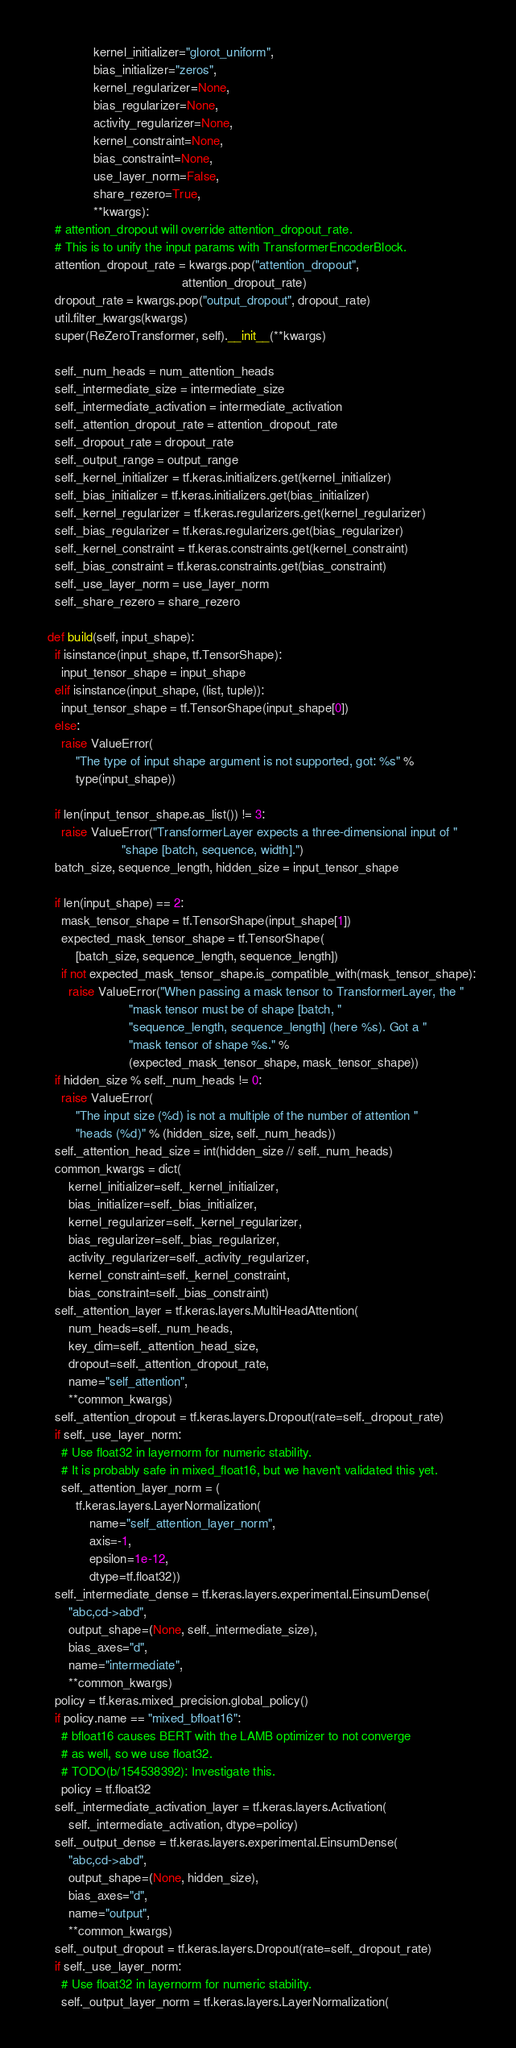Convert code to text. <code><loc_0><loc_0><loc_500><loc_500><_Python_>               kernel_initializer="glorot_uniform",
               bias_initializer="zeros",
               kernel_regularizer=None,
               bias_regularizer=None,
               activity_regularizer=None,
               kernel_constraint=None,
               bias_constraint=None,
               use_layer_norm=False,
               share_rezero=True,
               **kwargs):
    # attention_dropout will override attention_dropout_rate.
    # This is to unify the input params with TransformerEncoderBlock.
    attention_dropout_rate = kwargs.pop("attention_dropout",
                                        attention_dropout_rate)
    dropout_rate = kwargs.pop("output_dropout", dropout_rate)
    util.filter_kwargs(kwargs)
    super(ReZeroTransformer, self).__init__(**kwargs)

    self._num_heads = num_attention_heads
    self._intermediate_size = intermediate_size
    self._intermediate_activation = intermediate_activation
    self._attention_dropout_rate = attention_dropout_rate
    self._dropout_rate = dropout_rate
    self._output_range = output_range
    self._kernel_initializer = tf.keras.initializers.get(kernel_initializer)
    self._bias_initializer = tf.keras.initializers.get(bias_initializer)
    self._kernel_regularizer = tf.keras.regularizers.get(kernel_regularizer)
    self._bias_regularizer = tf.keras.regularizers.get(bias_regularizer)
    self._kernel_constraint = tf.keras.constraints.get(kernel_constraint)
    self._bias_constraint = tf.keras.constraints.get(bias_constraint)
    self._use_layer_norm = use_layer_norm
    self._share_rezero = share_rezero

  def build(self, input_shape):
    if isinstance(input_shape, tf.TensorShape):
      input_tensor_shape = input_shape
    elif isinstance(input_shape, (list, tuple)):
      input_tensor_shape = tf.TensorShape(input_shape[0])
    else:
      raise ValueError(
          "The type of input shape argument is not supported, got: %s" %
          type(input_shape))

    if len(input_tensor_shape.as_list()) != 3:
      raise ValueError("TransformerLayer expects a three-dimensional input of "
                       "shape [batch, sequence, width].")
    batch_size, sequence_length, hidden_size = input_tensor_shape

    if len(input_shape) == 2:
      mask_tensor_shape = tf.TensorShape(input_shape[1])
      expected_mask_tensor_shape = tf.TensorShape(
          [batch_size, sequence_length, sequence_length])
      if not expected_mask_tensor_shape.is_compatible_with(mask_tensor_shape):
        raise ValueError("When passing a mask tensor to TransformerLayer, the "
                         "mask tensor must be of shape [batch, "
                         "sequence_length, sequence_length] (here %s). Got a "
                         "mask tensor of shape %s." %
                         (expected_mask_tensor_shape, mask_tensor_shape))
    if hidden_size % self._num_heads != 0:
      raise ValueError(
          "The input size (%d) is not a multiple of the number of attention "
          "heads (%d)" % (hidden_size, self._num_heads))
    self._attention_head_size = int(hidden_size // self._num_heads)
    common_kwargs = dict(
        kernel_initializer=self._kernel_initializer,
        bias_initializer=self._bias_initializer,
        kernel_regularizer=self._kernel_regularizer,
        bias_regularizer=self._bias_regularizer,
        activity_regularizer=self._activity_regularizer,
        kernel_constraint=self._kernel_constraint,
        bias_constraint=self._bias_constraint)
    self._attention_layer = tf.keras.layers.MultiHeadAttention(
        num_heads=self._num_heads,
        key_dim=self._attention_head_size,
        dropout=self._attention_dropout_rate,
        name="self_attention",
        **common_kwargs)
    self._attention_dropout = tf.keras.layers.Dropout(rate=self._dropout_rate)
    if self._use_layer_norm:
      # Use float32 in layernorm for numeric stability.
      # It is probably safe in mixed_float16, but we haven't validated this yet.
      self._attention_layer_norm = (
          tf.keras.layers.LayerNormalization(
              name="self_attention_layer_norm",
              axis=-1,
              epsilon=1e-12,
              dtype=tf.float32))
    self._intermediate_dense = tf.keras.layers.experimental.EinsumDense(
        "abc,cd->abd",
        output_shape=(None, self._intermediate_size),
        bias_axes="d",
        name="intermediate",
        **common_kwargs)
    policy = tf.keras.mixed_precision.global_policy()
    if policy.name == "mixed_bfloat16":
      # bfloat16 causes BERT with the LAMB optimizer to not converge
      # as well, so we use float32.
      # TODO(b/154538392): Investigate this.
      policy = tf.float32
    self._intermediate_activation_layer = tf.keras.layers.Activation(
        self._intermediate_activation, dtype=policy)
    self._output_dense = tf.keras.layers.experimental.EinsumDense(
        "abc,cd->abd",
        output_shape=(None, hidden_size),
        bias_axes="d",
        name="output",
        **common_kwargs)
    self._output_dropout = tf.keras.layers.Dropout(rate=self._dropout_rate)
    if self._use_layer_norm:
      # Use float32 in layernorm for numeric stability.
      self._output_layer_norm = tf.keras.layers.LayerNormalization(</code> 